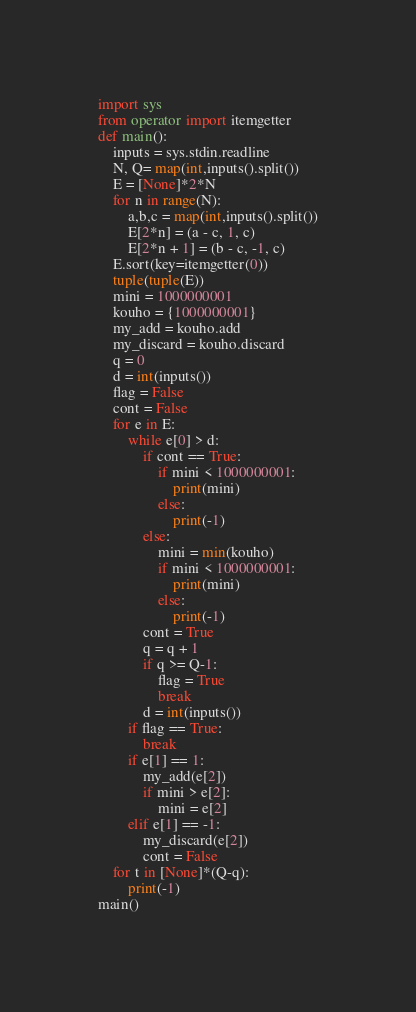<code> <loc_0><loc_0><loc_500><loc_500><_Python_>import sys
from operator import itemgetter
def main():
	inputs = sys.stdin.readline
	N, Q= map(int,inputs().split())
	E = [None]*2*N
	for n in range(N):
		a,b,c = map(int,inputs().split())
		E[2*n] = (a - c, 1, c)
		E[2*n + 1] = (b - c, -1, c)
	E.sort(key=itemgetter(0))
	tuple(tuple(E))
	mini = 1000000001
	kouho = {1000000001}
	my_add = kouho.add
	my_discard = kouho.discard
	q = 0
	d = int(inputs())
	flag = False
	cont = False
	for e in E:
		while e[0] > d:
			if cont == True:
				if mini < 1000000001:
					print(mini)
				else:
					print(-1)
			else:
				mini = min(kouho)
				if mini < 1000000001:
					print(mini)
				else:
					print(-1)
			cont = True
			q = q + 1
			if q >= Q-1:
				flag = True
				break
			d = int(inputs())
		if flag == True:
			break
		if e[1] == 1:
			my_add(e[2])
			if mini > e[2]:
				mini = e[2]
		elif e[1] == -1:
			my_discard(e[2])
			cont = False
	for t in [None]*(Q-q):
		print(-1)
main()</code> 